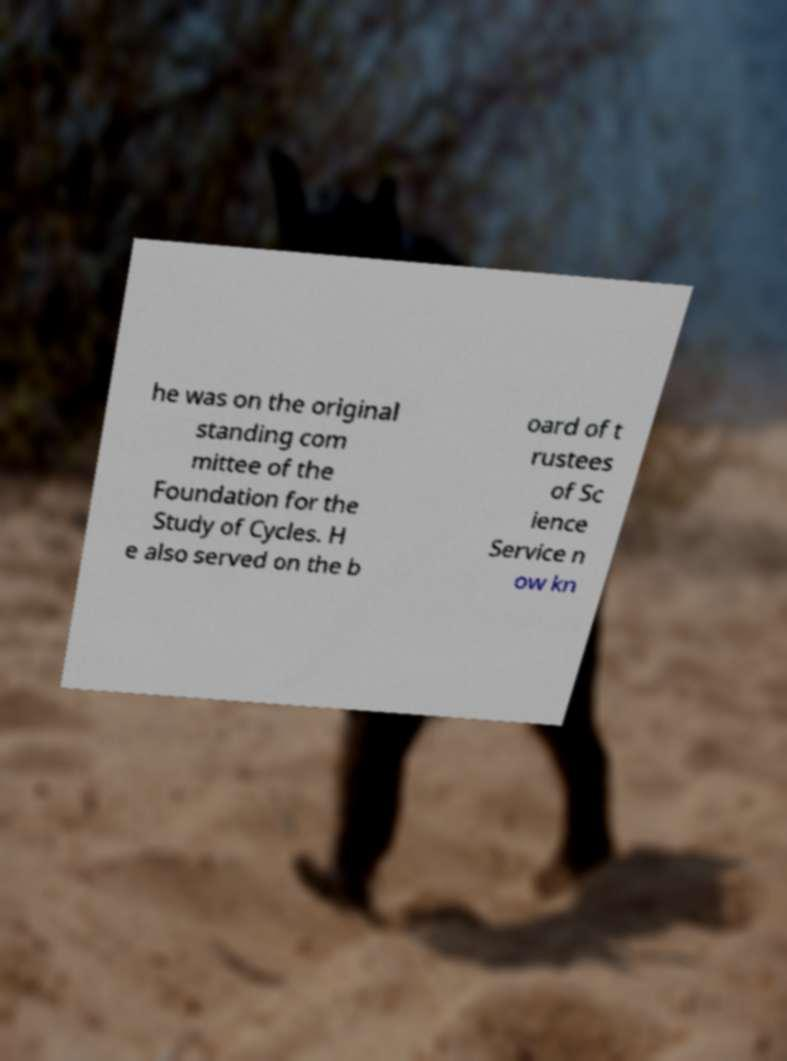Could you assist in decoding the text presented in this image and type it out clearly? he was on the original standing com mittee of the Foundation for the Study of Cycles. H e also served on the b oard of t rustees of Sc ience Service n ow kn 